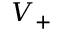Convert formula to latex. <formula><loc_0><loc_0><loc_500><loc_500>V _ { + }</formula> 